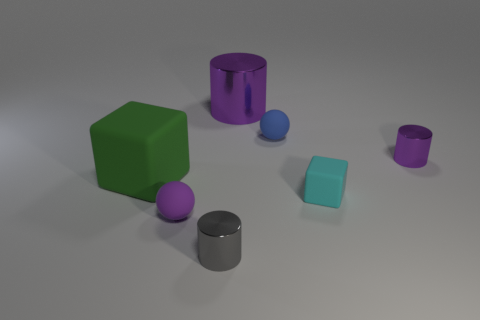How many purple cylinders must be subtracted to get 1 purple cylinders? 1 Subtract 1 cylinders. How many cylinders are left? 2 Subtract all brown cubes. How many purple cylinders are left? 2 Subtract all purple metal cylinders. How many cylinders are left? 1 Add 3 gray things. How many objects exist? 10 Add 1 tiny cyan metallic objects. How many tiny cyan metallic objects exist? 1 Subtract 0 yellow cubes. How many objects are left? 7 Subtract all spheres. How many objects are left? 5 Subtract all small green cylinders. Subtract all tiny shiny objects. How many objects are left? 5 Add 5 blue things. How many blue things are left? 6 